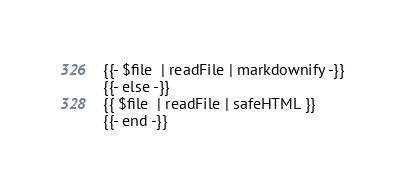Convert code to text. <code><loc_0><loc_0><loc_500><loc_500><_HTML_>{{- $file  | readFile | markdownify -}}
{{- else -}}
{{ $file  | readFile | safeHTML }}
{{- end -}}</code> 